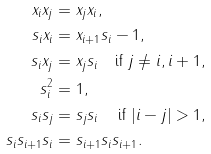<formula> <loc_0><loc_0><loc_500><loc_500>x _ { i } x _ { j } & = x _ { j } x _ { i } , \\ s _ { i } x _ { i } & = x _ { i + 1 } s _ { i } - 1 , \\ s _ { i } x _ { j } & = x _ { j } s _ { i } \quad \text {if } j \neq i , i + 1 , \\ s _ { i } ^ { 2 } & = 1 , \\ s _ { i } s _ { j } & = s _ { j } s _ { i } \quad \text {\,if } | i - j | > 1 , \\ s _ { i } s _ { i + 1 } s _ { i } & = s _ { i + 1 } s _ { i } s _ { i + 1 } .</formula> 